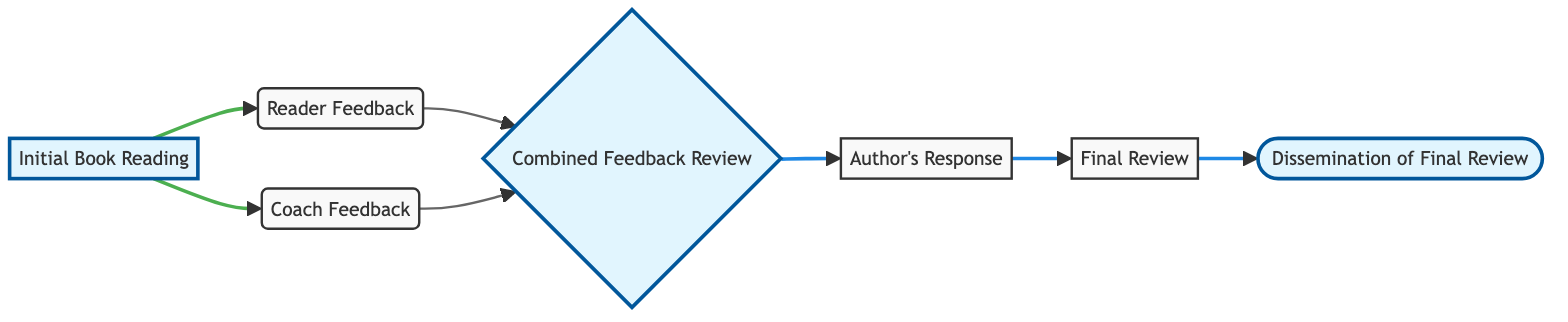What is the first step in the feedback process? The diagram begins at the node labeled "Initial Book Reading," which is the first step where readers start engaging with the book.
Answer: Initial Book Reading How many total nodes are in the diagram? To find the total number of nodes, we can count the unique labeled nodes listed in the diagram. There are seven nodes in total.
Answer: 7 What do readers provide after initial reading? After the initial reading, readers provide feedback, which is indicated by the "Reader Feedback" node. This feedback is essential for the subsequent process.
Answer: Reader Feedback What is required before the author's response? Before the author's response can occur, there must be a "Combined Feedback Review." This step aggregates inputs from both reader and coach feedback before the author acts on it.
Answer: Combined Feedback Review Which node connects "Coach Feedback" and "Combined Feedback Review"? The edge that connects "Coach Feedback" to "Combined Feedback Review" indicates the flow of information from the coach to the review process. Therefore, "Combined Feedback Review" is directly connected to "Coach Feedback."
Answer: Combined Feedback Review What is the last step shown in the diagram? The last step in the flow of the diagram is "Dissemination of Final Review." This indicates how the final review is shared or communicated after the author's response has been processed.
Answer: Dissemination of Final Review How many edges connect the "Initial Book Reading" node? "Initial Book Reading" is connected by two edges, one to "Reader Feedback" and one to "Coach Feedback," showing two pathways of feedback from this starting point.
Answer: 2 What step combines feedback from both readers and coaches? The "Combined Feedback Review" step serves to synthesize feedback received from both the readers and the coach, ensuring a comprehensive evaluation before moving to the author's response.
Answer: Combined Feedback Review Which node comes directly before the "Final Review"? The node that comes directly before "Final Review" is "Author's Response." The flow indicates that after the author responds, the review is finalized.
Answer: Author's Response 